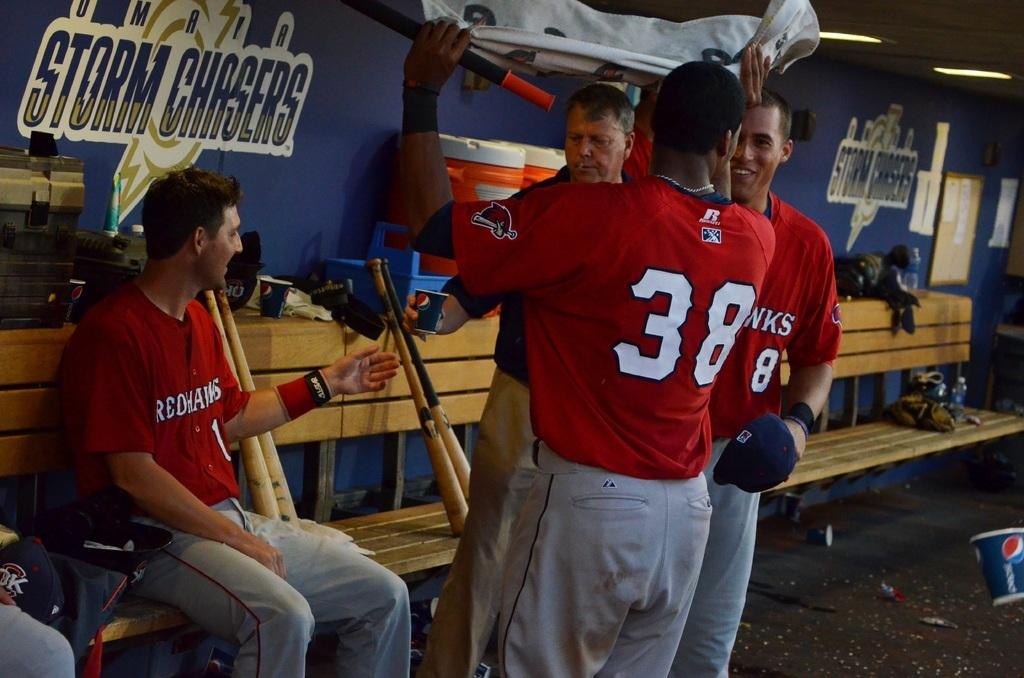<image>
Render a clear and concise summary of the photo. Player #38 is chatting with his teammates after the match. 